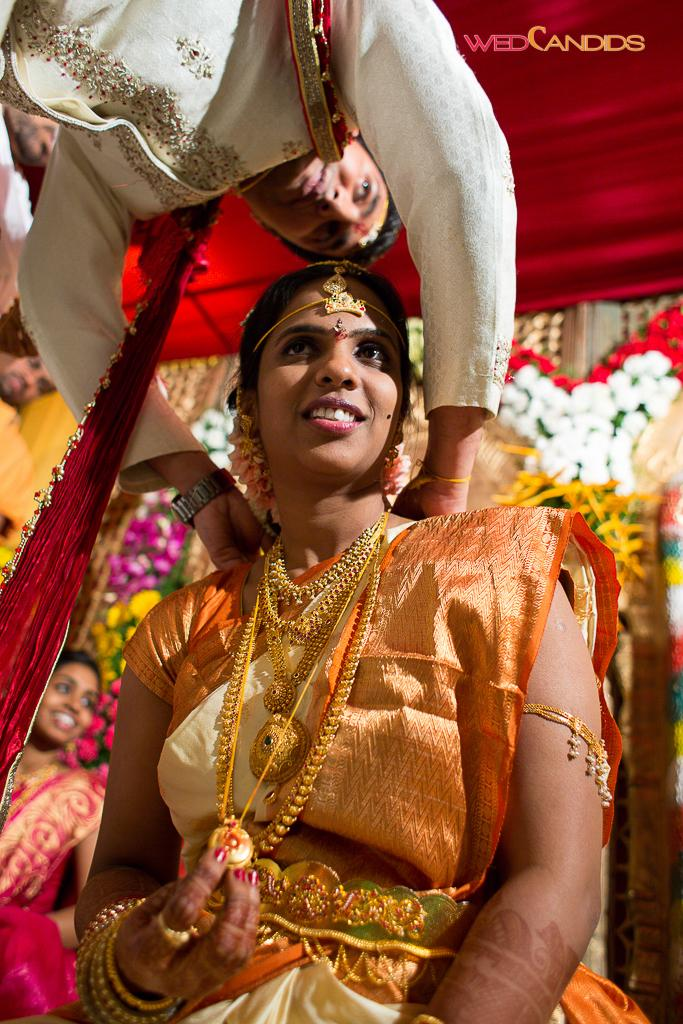What event is taking place in the image? The image depicts a wedding. What are the people in the image wearing? The people in the image are wearing clothes. What can be seen in the background of the image? There are flowers in the background of the image. Can you see any needles or stitches on the clothes of the people in the image? There is no reference to needles or stitches in the image, as it depicts a wedding and not the process of making clothes. 